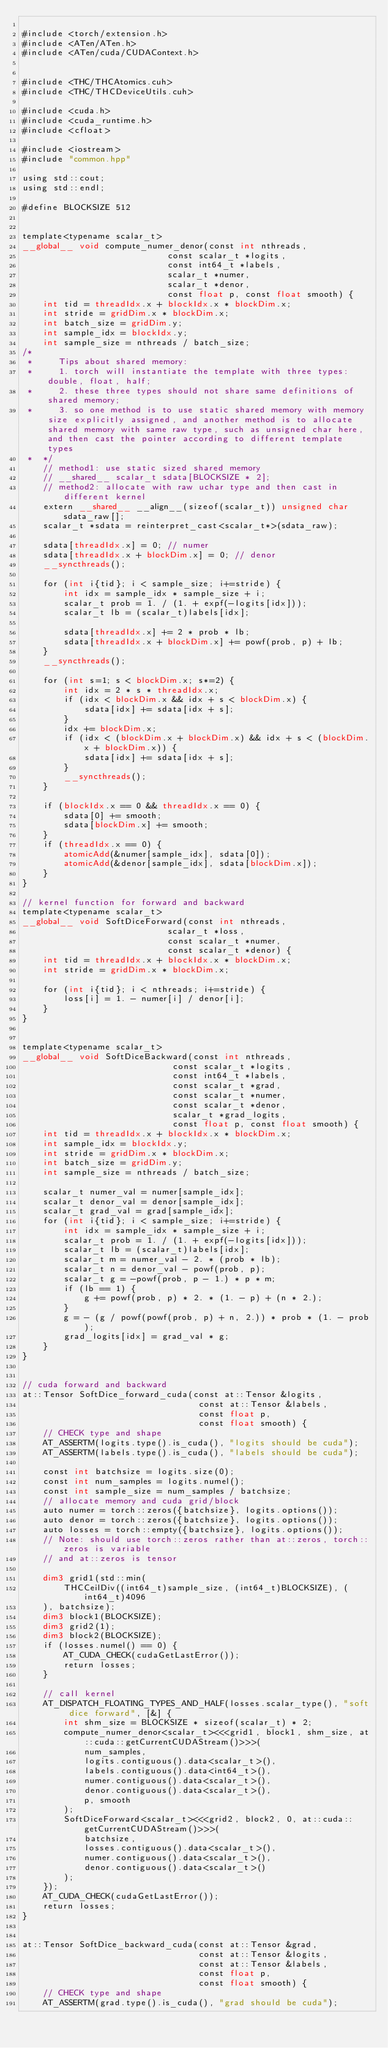<code> <loc_0><loc_0><loc_500><loc_500><_Cuda_>
#include <torch/extension.h>
#include <ATen/ATen.h>
#include <ATen/cuda/CUDAContext.h>


#include <THC/THCAtomics.cuh>
#include <THC/THCDeviceUtils.cuh>

#include <cuda.h>
#include <cuda_runtime.h>
#include <cfloat>

#include <iostream>
#include "common.hpp"

using std::cout;
using std::endl;

#define BLOCKSIZE 512


template<typename scalar_t>
__global__ void compute_numer_denor(const int nthreads,
                            const scalar_t *logits,
                            const int64_t *labels,
                            scalar_t *numer,
                            scalar_t *denor,
                            const float p, const float smooth) {
    int tid = threadIdx.x + blockIdx.x * blockDim.x;
    int stride = gridDim.x * blockDim.x;
    int batch_size = gridDim.y;
    int sample_idx = blockIdx.y;
    int sample_size = nthreads / batch_size;
/* 
 *     Tips about shared memory:
 *     1. torch will instantiate the template with three types: double, float, half;
 *     2. these three types should not share same definitions of shared memory;
 *     3. so one method is to use static shared memory with memory size explicitly assigned, and another method is to allocate shared memory with same raw type, such as unsigned char here, and then cast the pointer according to different template types
 *  */
    // method1: use static sized shared memory
    // __shared__ scalar_t sdata[BLOCKSIZE * 2];
    // method2: allocate with raw uchar type and then cast in different kernel
    extern __shared__ __align__(sizeof(scalar_t)) unsigned char sdata_raw[];
    scalar_t *sdata = reinterpret_cast<scalar_t*>(sdata_raw);

    sdata[threadIdx.x] = 0; // numer
    sdata[threadIdx.x + blockDim.x] = 0; // denor
    __syncthreads();

    for (int i{tid}; i < sample_size; i+=stride) {
        int idx = sample_idx * sample_size + i;
        scalar_t prob = 1. / (1. + expf(-logits[idx]));
        scalar_t lb = (scalar_t)labels[idx];

        sdata[threadIdx.x] += 2 * prob * lb;
        sdata[threadIdx.x + blockDim.x] += powf(prob, p) + lb;
    }
    __syncthreads();

    for (int s=1; s < blockDim.x; s*=2) {
        int idx = 2 * s * threadIdx.x;
        if (idx < blockDim.x && idx + s < blockDim.x) {
            sdata[idx] += sdata[idx + s];
        }
        idx += blockDim.x;
        if (idx < (blockDim.x + blockDim.x) && idx + s < (blockDim.x + blockDim.x)) {
            sdata[idx] += sdata[idx + s];
        }
        __syncthreads();
    }

    if (blockIdx.x == 0 && threadIdx.x == 0) {
        sdata[0] += smooth;
        sdata[blockDim.x] += smooth;
    }
    if (threadIdx.x == 0) {
        atomicAdd(&numer[sample_idx], sdata[0]);
        atomicAdd(&denor[sample_idx], sdata[blockDim.x]);
    }
}

// kernel function for forward and backward
template<typename scalar_t>
__global__ void SoftDiceForward(const int nthreads,
                            scalar_t *loss,
                            const scalar_t *numer,
                            const scalar_t *denor) {
    int tid = threadIdx.x + blockIdx.x * blockDim.x;
    int stride = gridDim.x * blockDim.x;

    for (int i{tid}; i < nthreads; i+=stride) {
        loss[i] = 1. - numer[i] / denor[i];
    }
}


template<typename scalar_t>
__global__ void SoftDiceBackward(const int nthreads,
                             const scalar_t *logits,
                             const int64_t *labels,
                             const scalar_t *grad,
                             const scalar_t *numer,
                             const scalar_t *denor,
                             scalar_t *grad_logits,
                             const float p, const float smooth) {
    int tid = threadIdx.x + blockIdx.x * blockDim.x;
    int sample_idx = blockIdx.y;
    int stride = gridDim.x * blockDim.x;
    int batch_size = gridDim.y;
    int sample_size = nthreads / batch_size;

    scalar_t numer_val = numer[sample_idx];
    scalar_t denor_val = denor[sample_idx];
    scalar_t grad_val = grad[sample_idx];
    for (int i{tid}; i < sample_size; i+=stride) {
        int idx = sample_idx * sample_size + i;
        scalar_t prob = 1. / (1. + expf(-logits[idx]));
        scalar_t lb = (scalar_t)labels[idx];
        scalar_t m = numer_val - 2. * (prob * lb);
        scalar_t n = denor_val - powf(prob, p);
        scalar_t g = -powf(prob, p - 1.) * p * m;
        if (lb == 1) {
            g += powf(prob, p) * 2. * (1. - p) + (n * 2.);
        }
        g = - (g / powf(powf(prob, p) + n, 2.)) * prob * (1. - prob);
        grad_logits[idx] = grad_val * g;
    }
}


// cuda forward and backward
at::Tensor SoftDice_forward_cuda(const at::Tensor &logits,
                                  const at::Tensor &labels,
                                  const float p,
                                  const float smooth) {
    // CHECK type and shape
    AT_ASSERTM(logits.type().is_cuda(), "logits should be cuda");
    AT_ASSERTM(labels.type().is_cuda(), "labels should be cuda");

    const int batchsize = logits.size(0);
    const int num_samples = logits.numel();
    const int sample_size = num_samples / batchsize;
    // allocate memory and cuda grid/block
    auto numer = torch::zeros({batchsize}, logits.options());
    auto denor = torch::zeros({batchsize}, logits.options());
    auto losses = torch::empty({batchsize}, logits.options());
    // Note: should use torch::zeros rather than at::zeros, torch::zeros is variable
    // and at::zeros is tensor

    dim3 grid1(std::min(
        THCCeilDiv((int64_t)sample_size, (int64_t)BLOCKSIZE), (int64_t)4096
    ), batchsize);
    dim3 block1(BLOCKSIZE);
    dim3 grid2(1);
    dim3 block2(BLOCKSIZE);
    if (losses.numel() == 0) {
        AT_CUDA_CHECK(cudaGetLastError());
        return losses;
    }

    // call kernel
    AT_DISPATCH_FLOATING_TYPES_AND_HALF(losses.scalar_type(), "soft dice forward", [&] {
        int shm_size = BLOCKSIZE * sizeof(scalar_t) * 2;
        compute_numer_denor<scalar_t><<<grid1, block1, shm_size, at::cuda::getCurrentCUDAStream()>>>(
            num_samples, 
            logits.contiguous().data<scalar_t>(), 
            labels.contiguous().data<int64_t>(), 
            numer.contiguous().data<scalar_t>(),
            denor.contiguous().data<scalar_t>(),
            p, smooth
        );
        SoftDiceForward<scalar_t><<<grid2, block2, 0, at::cuda::getCurrentCUDAStream()>>>(
            batchsize,
            losses.contiguous().data<scalar_t>(),
            numer.contiguous().data<scalar_t>(),
            denor.contiguous().data<scalar_t>()
        );
    });
    AT_CUDA_CHECK(cudaGetLastError());
    return losses;
}


at::Tensor SoftDice_backward_cuda(const at::Tensor &grad,
                                  const at::Tensor &logits,
                                  const at::Tensor &labels,
                                  const float p,
                                  const float smooth) {
    // CHECK type and shape
    AT_ASSERTM(grad.type().is_cuda(), "grad should be cuda");</code> 